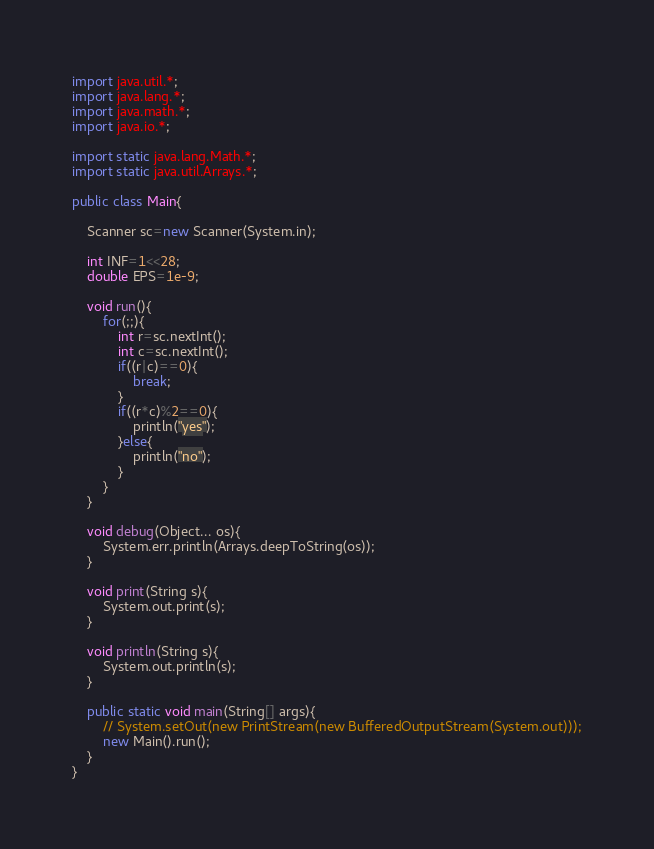<code> <loc_0><loc_0><loc_500><loc_500><_Java_>import java.util.*;
import java.lang.*;
import java.math.*;
import java.io.*;

import static java.lang.Math.*;
import static java.util.Arrays.*;

public class Main{

	Scanner sc=new Scanner(System.in);

	int INF=1<<28;
	double EPS=1e-9;

	void run(){
		for(;;){
			int r=sc.nextInt();
			int c=sc.nextInt();
			if((r|c)==0){
				break;
			}
			if((r*c)%2==0){
				println("yes");
			}else{
				println("no");
			}
		}
	}

	void debug(Object... os){
		System.err.println(Arrays.deepToString(os));
	}

	void print(String s){
		System.out.print(s);
	}

	void println(String s){
		System.out.println(s);
	}

	public static void main(String[] args){
		// System.setOut(new PrintStream(new BufferedOutputStream(System.out)));
		new Main().run();
	}
}</code> 